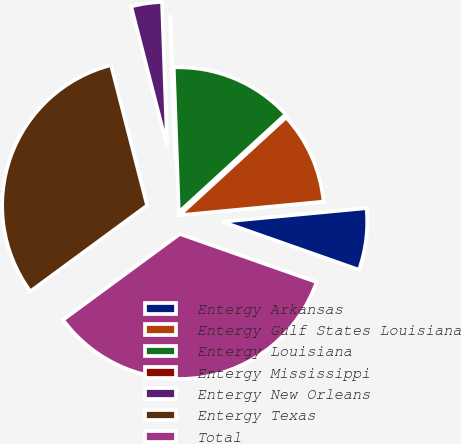<chart> <loc_0><loc_0><loc_500><loc_500><pie_chart><fcel>Entergy Arkansas<fcel>Entergy Gulf States Louisiana<fcel>Entergy Louisiana<fcel>Entergy Mississippi<fcel>Entergy New Orleans<fcel>Entergy Texas<fcel>Total<nl><fcel>6.88%<fcel>10.31%<fcel>13.75%<fcel>0.0%<fcel>3.44%<fcel>31.09%<fcel>34.53%<nl></chart> 